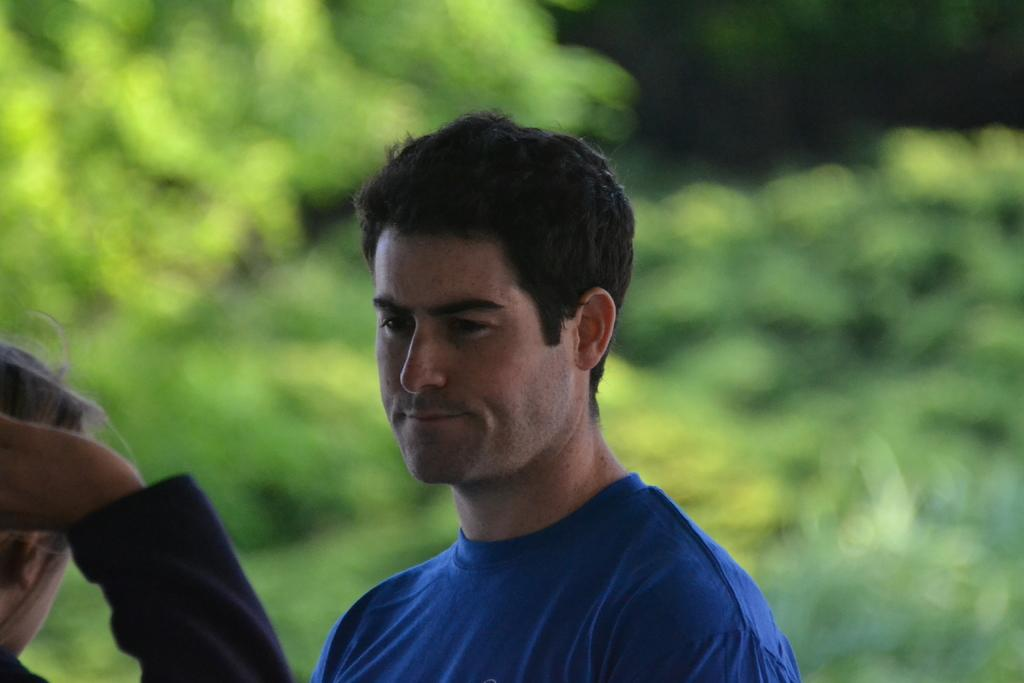How many people are in the image? There are two persons in the image. Where are the two persons located in the image? The two persons are at the front of the image. What can be seen in the background of the image? There are trees in the background of the image. What type of soap is being used by the persons in the image? There is no soap present in the image; it features two persons at the front with trees in the background. 